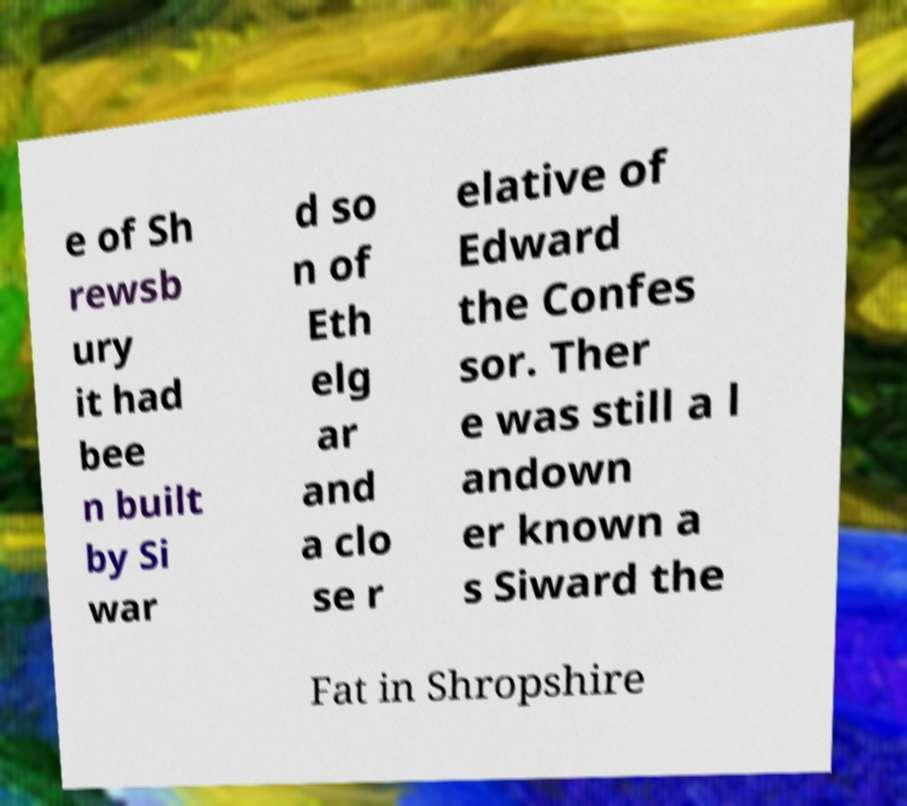Please read and relay the text visible in this image. What does it say? e of Sh rewsb ury it had bee n built by Si war d so n of Eth elg ar and a clo se r elative of Edward the Confes sor. Ther e was still a l andown er known a s Siward the Fat in Shropshire 